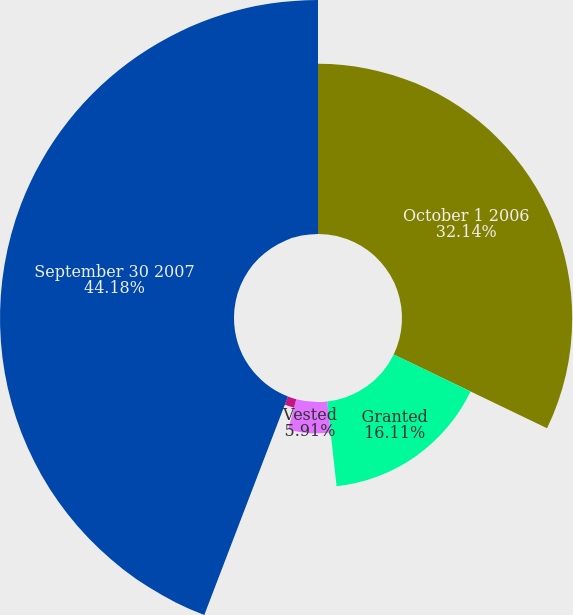Convert chart. <chart><loc_0><loc_0><loc_500><loc_500><pie_chart><fcel>October 1 2006<fcel>Granted<fcel>Vested<fcel>Canceled<fcel>September 30 2007<nl><fcel>32.14%<fcel>16.11%<fcel>5.91%<fcel>1.66%<fcel>44.18%<nl></chart> 